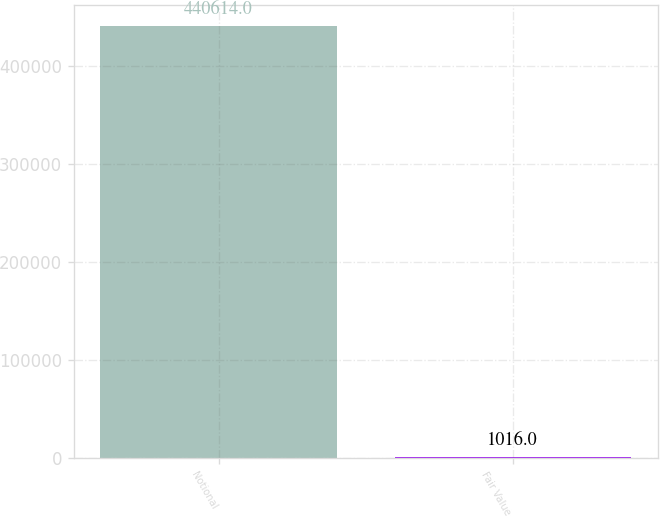Convert chart to OTSL. <chart><loc_0><loc_0><loc_500><loc_500><bar_chart><fcel>Notional<fcel>Fair Value<nl><fcel>440614<fcel>1016<nl></chart> 